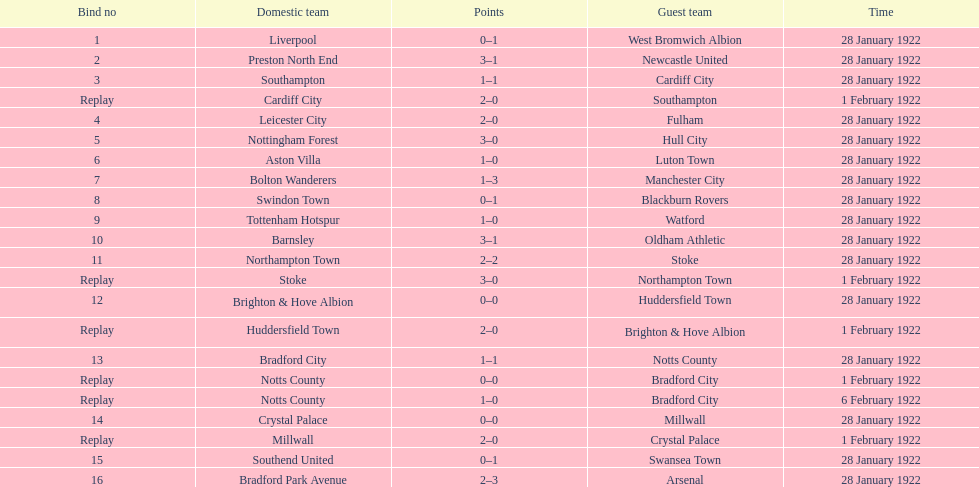In how many games were four or more total points scored? 5. 